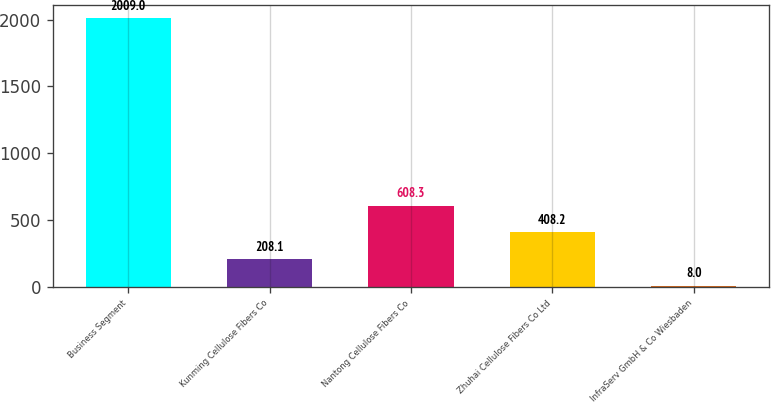Convert chart to OTSL. <chart><loc_0><loc_0><loc_500><loc_500><bar_chart><fcel>Business Segment<fcel>Kunming Cellulose Fibers Co<fcel>Nantong Cellulose Fibers Co<fcel>Zhuhai Cellulose Fibers Co Ltd<fcel>InfraServ GmbH & Co Wiesbaden<nl><fcel>2009<fcel>208.1<fcel>608.3<fcel>408.2<fcel>8<nl></chart> 